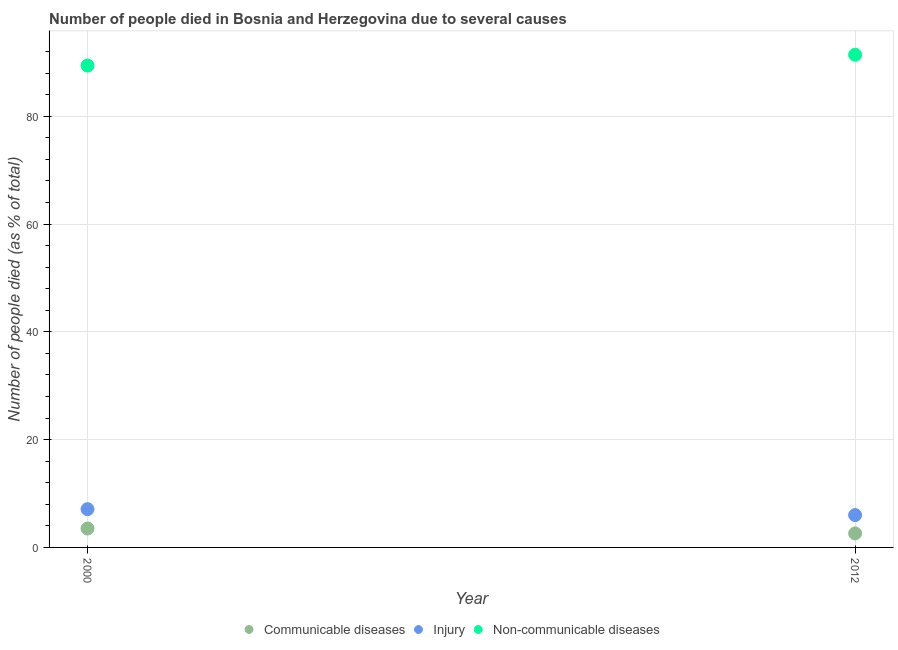How many different coloured dotlines are there?
Make the answer very short. 3. Across all years, what is the maximum number of people who died of communicable diseases?
Offer a very short reply. 3.5. Across all years, what is the minimum number of people who died of communicable diseases?
Offer a very short reply. 2.6. In which year was the number of people who died of injury minimum?
Your response must be concise. 2012. What is the difference between the number of people who dies of non-communicable diseases in 2000 and that in 2012?
Ensure brevity in your answer.  -2. What is the difference between the number of people who died of communicable diseases in 2012 and the number of people who dies of non-communicable diseases in 2000?
Provide a succinct answer. -86.8. What is the average number of people who died of communicable diseases per year?
Your response must be concise. 3.05. In how many years, is the number of people who died of injury greater than 28 %?
Give a very brief answer. 0. What is the ratio of the number of people who dies of non-communicable diseases in 2000 to that in 2012?
Keep it short and to the point. 0.98. Is the number of people who died of injury in 2000 less than that in 2012?
Your answer should be compact. No. Is the number of people who died of communicable diseases strictly less than the number of people who died of injury over the years?
Your response must be concise. Yes. What is the difference between two consecutive major ticks on the Y-axis?
Your response must be concise. 20. Are the values on the major ticks of Y-axis written in scientific E-notation?
Offer a very short reply. No. Does the graph contain any zero values?
Offer a very short reply. No. Does the graph contain grids?
Provide a succinct answer. Yes. How are the legend labels stacked?
Make the answer very short. Horizontal. What is the title of the graph?
Your answer should be compact. Number of people died in Bosnia and Herzegovina due to several causes. What is the label or title of the Y-axis?
Your answer should be compact. Number of people died (as % of total). What is the Number of people died (as % of total) of Non-communicable diseases in 2000?
Your response must be concise. 89.4. What is the Number of people died (as % of total) in Non-communicable diseases in 2012?
Keep it short and to the point. 91.4. Across all years, what is the maximum Number of people died (as % of total) of Communicable diseases?
Offer a terse response. 3.5. Across all years, what is the maximum Number of people died (as % of total) in Injury?
Offer a very short reply. 7.1. Across all years, what is the maximum Number of people died (as % of total) in Non-communicable diseases?
Your answer should be very brief. 91.4. Across all years, what is the minimum Number of people died (as % of total) in Injury?
Your answer should be compact. 6. Across all years, what is the minimum Number of people died (as % of total) of Non-communicable diseases?
Provide a succinct answer. 89.4. What is the total Number of people died (as % of total) of Communicable diseases in the graph?
Offer a terse response. 6.1. What is the total Number of people died (as % of total) in Injury in the graph?
Ensure brevity in your answer.  13.1. What is the total Number of people died (as % of total) in Non-communicable diseases in the graph?
Give a very brief answer. 180.8. What is the difference between the Number of people died (as % of total) of Injury in 2000 and that in 2012?
Offer a terse response. 1.1. What is the difference between the Number of people died (as % of total) in Communicable diseases in 2000 and the Number of people died (as % of total) in Non-communicable diseases in 2012?
Your answer should be compact. -87.9. What is the difference between the Number of people died (as % of total) of Injury in 2000 and the Number of people died (as % of total) of Non-communicable diseases in 2012?
Your response must be concise. -84.3. What is the average Number of people died (as % of total) in Communicable diseases per year?
Give a very brief answer. 3.05. What is the average Number of people died (as % of total) of Injury per year?
Keep it short and to the point. 6.55. What is the average Number of people died (as % of total) of Non-communicable diseases per year?
Provide a short and direct response. 90.4. In the year 2000, what is the difference between the Number of people died (as % of total) in Communicable diseases and Number of people died (as % of total) in Non-communicable diseases?
Make the answer very short. -85.9. In the year 2000, what is the difference between the Number of people died (as % of total) in Injury and Number of people died (as % of total) in Non-communicable diseases?
Make the answer very short. -82.3. In the year 2012, what is the difference between the Number of people died (as % of total) of Communicable diseases and Number of people died (as % of total) of Non-communicable diseases?
Make the answer very short. -88.8. In the year 2012, what is the difference between the Number of people died (as % of total) of Injury and Number of people died (as % of total) of Non-communicable diseases?
Provide a succinct answer. -85.4. What is the ratio of the Number of people died (as % of total) of Communicable diseases in 2000 to that in 2012?
Ensure brevity in your answer.  1.35. What is the ratio of the Number of people died (as % of total) of Injury in 2000 to that in 2012?
Make the answer very short. 1.18. What is the ratio of the Number of people died (as % of total) in Non-communicable diseases in 2000 to that in 2012?
Offer a very short reply. 0.98. What is the difference between the highest and the second highest Number of people died (as % of total) in Communicable diseases?
Provide a succinct answer. 0.9. What is the difference between the highest and the lowest Number of people died (as % of total) in Communicable diseases?
Your response must be concise. 0.9. What is the difference between the highest and the lowest Number of people died (as % of total) of Injury?
Your answer should be compact. 1.1. What is the difference between the highest and the lowest Number of people died (as % of total) in Non-communicable diseases?
Make the answer very short. 2. 